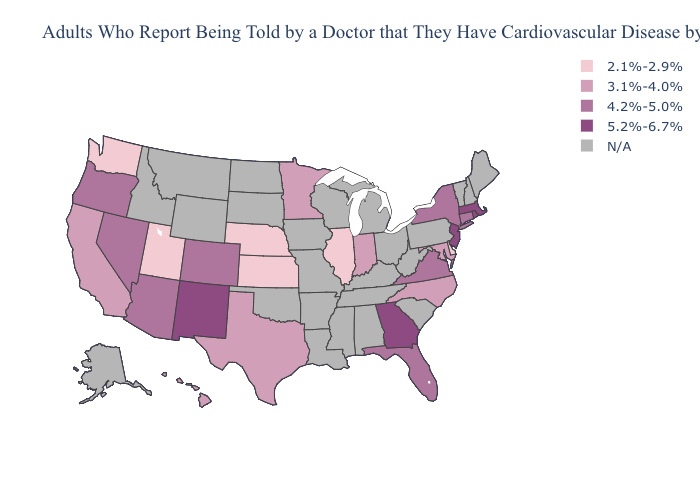Among the states that border Iowa , which have the lowest value?
Short answer required. Illinois, Nebraska. Name the states that have a value in the range 4.2%-5.0%?
Write a very short answer. Arizona, Colorado, Connecticut, Florida, Nevada, New York, Oregon, Virginia. What is the lowest value in the MidWest?
Short answer required. 2.1%-2.9%. Name the states that have a value in the range N/A?
Short answer required. Alabama, Alaska, Arkansas, Idaho, Iowa, Kentucky, Louisiana, Maine, Michigan, Mississippi, Missouri, Montana, New Hampshire, North Dakota, Ohio, Oklahoma, Pennsylvania, South Carolina, South Dakota, Tennessee, Vermont, West Virginia, Wisconsin, Wyoming. Name the states that have a value in the range N/A?
Short answer required. Alabama, Alaska, Arkansas, Idaho, Iowa, Kentucky, Louisiana, Maine, Michigan, Mississippi, Missouri, Montana, New Hampshire, North Dakota, Ohio, Oklahoma, Pennsylvania, South Carolina, South Dakota, Tennessee, Vermont, West Virginia, Wisconsin, Wyoming. Which states hav the highest value in the West?
Quick response, please. New Mexico. What is the lowest value in the USA?
Short answer required. 2.1%-2.9%. Does New York have the highest value in the Northeast?
Give a very brief answer. No. What is the highest value in the South ?
Quick response, please. 5.2%-6.7%. What is the value of Indiana?
Write a very short answer. 3.1%-4.0%. Name the states that have a value in the range 2.1%-2.9%?
Give a very brief answer. Delaware, Illinois, Kansas, Nebraska, Utah, Washington. What is the value of Nebraska?
Keep it brief. 2.1%-2.9%. Which states have the lowest value in the USA?
Quick response, please. Delaware, Illinois, Kansas, Nebraska, Utah, Washington. Name the states that have a value in the range 2.1%-2.9%?
Be succinct. Delaware, Illinois, Kansas, Nebraska, Utah, Washington. 